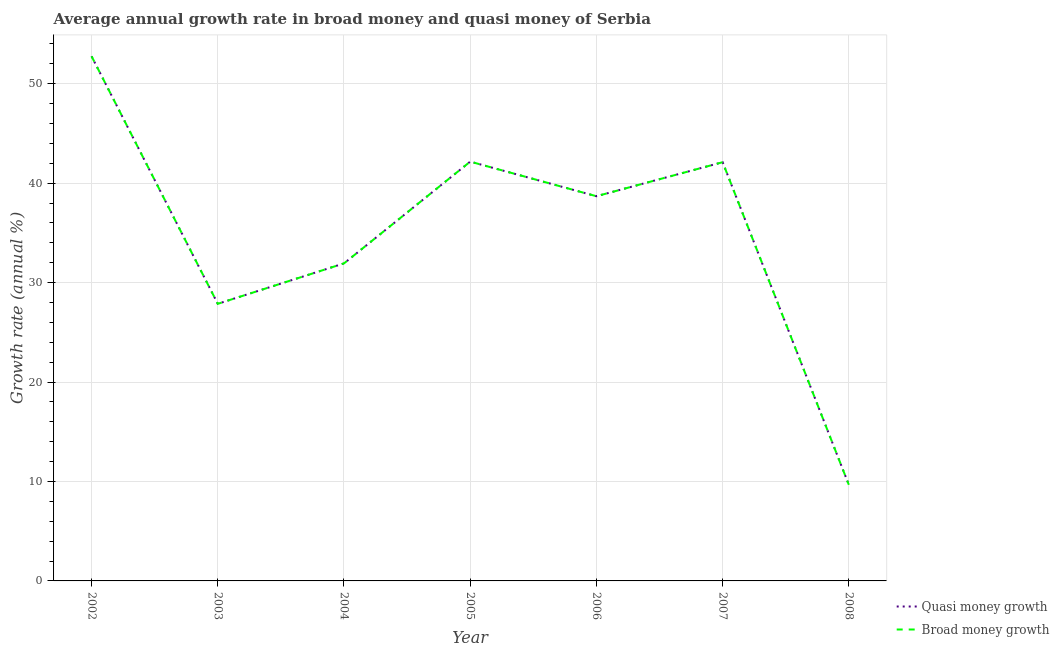How many different coloured lines are there?
Offer a terse response. 2. What is the annual growth rate in broad money in 2002?
Your response must be concise. 52.76. Across all years, what is the maximum annual growth rate in quasi money?
Offer a terse response. 52.76. Across all years, what is the minimum annual growth rate in broad money?
Your answer should be compact. 9.67. In which year was the annual growth rate in broad money maximum?
Offer a very short reply. 2002. In which year was the annual growth rate in quasi money minimum?
Offer a very short reply. 2008. What is the total annual growth rate in quasi money in the graph?
Provide a short and direct response. 245.19. What is the difference between the annual growth rate in quasi money in 2002 and that in 2006?
Provide a short and direct response. 14.07. What is the difference between the annual growth rate in quasi money in 2007 and the annual growth rate in broad money in 2005?
Your answer should be compact. -0.06. What is the average annual growth rate in broad money per year?
Provide a short and direct response. 35.03. What is the ratio of the annual growth rate in broad money in 2006 to that in 2007?
Make the answer very short. 0.92. What is the difference between the highest and the second highest annual growth rate in quasi money?
Give a very brief answer. 10.59. What is the difference between the highest and the lowest annual growth rate in quasi money?
Your response must be concise. 43.09. In how many years, is the annual growth rate in quasi money greater than the average annual growth rate in quasi money taken over all years?
Provide a succinct answer. 4. What is the difference between two consecutive major ticks on the Y-axis?
Offer a very short reply. 10. Are the values on the major ticks of Y-axis written in scientific E-notation?
Keep it short and to the point. No. Does the graph contain any zero values?
Offer a terse response. No. Does the graph contain grids?
Make the answer very short. Yes. Where does the legend appear in the graph?
Offer a very short reply. Bottom right. How many legend labels are there?
Make the answer very short. 2. How are the legend labels stacked?
Make the answer very short. Vertical. What is the title of the graph?
Offer a very short reply. Average annual growth rate in broad money and quasi money of Serbia. What is the label or title of the Y-axis?
Provide a succinct answer. Growth rate (annual %). What is the Growth rate (annual %) of Quasi money growth in 2002?
Ensure brevity in your answer.  52.76. What is the Growth rate (annual %) in Broad money growth in 2002?
Provide a succinct answer. 52.76. What is the Growth rate (annual %) in Quasi money growth in 2003?
Provide a short and direct response. 27.87. What is the Growth rate (annual %) in Broad money growth in 2003?
Offer a very short reply. 27.87. What is the Growth rate (annual %) of Quasi money growth in 2004?
Your response must be concise. 31.93. What is the Growth rate (annual %) of Broad money growth in 2004?
Offer a very short reply. 31.93. What is the Growth rate (annual %) in Quasi money growth in 2005?
Your answer should be very brief. 42.17. What is the Growth rate (annual %) of Broad money growth in 2005?
Make the answer very short. 42.17. What is the Growth rate (annual %) of Quasi money growth in 2006?
Make the answer very short. 38.69. What is the Growth rate (annual %) in Broad money growth in 2006?
Your answer should be very brief. 38.69. What is the Growth rate (annual %) of Quasi money growth in 2007?
Your response must be concise. 42.11. What is the Growth rate (annual %) in Broad money growth in 2007?
Offer a terse response. 42.11. What is the Growth rate (annual %) of Quasi money growth in 2008?
Keep it short and to the point. 9.67. What is the Growth rate (annual %) in Broad money growth in 2008?
Offer a terse response. 9.67. Across all years, what is the maximum Growth rate (annual %) of Quasi money growth?
Provide a succinct answer. 52.76. Across all years, what is the maximum Growth rate (annual %) in Broad money growth?
Provide a succinct answer. 52.76. Across all years, what is the minimum Growth rate (annual %) of Quasi money growth?
Ensure brevity in your answer.  9.67. Across all years, what is the minimum Growth rate (annual %) of Broad money growth?
Your response must be concise. 9.67. What is the total Growth rate (annual %) of Quasi money growth in the graph?
Your answer should be very brief. 245.19. What is the total Growth rate (annual %) of Broad money growth in the graph?
Offer a very short reply. 245.19. What is the difference between the Growth rate (annual %) in Quasi money growth in 2002 and that in 2003?
Provide a short and direct response. 24.89. What is the difference between the Growth rate (annual %) of Broad money growth in 2002 and that in 2003?
Give a very brief answer. 24.89. What is the difference between the Growth rate (annual %) of Quasi money growth in 2002 and that in 2004?
Your answer should be compact. 20.83. What is the difference between the Growth rate (annual %) of Broad money growth in 2002 and that in 2004?
Give a very brief answer. 20.83. What is the difference between the Growth rate (annual %) in Quasi money growth in 2002 and that in 2005?
Ensure brevity in your answer.  10.59. What is the difference between the Growth rate (annual %) of Broad money growth in 2002 and that in 2005?
Your response must be concise. 10.59. What is the difference between the Growth rate (annual %) of Quasi money growth in 2002 and that in 2006?
Offer a very short reply. 14.07. What is the difference between the Growth rate (annual %) of Broad money growth in 2002 and that in 2006?
Offer a terse response. 14.07. What is the difference between the Growth rate (annual %) in Quasi money growth in 2002 and that in 2007?
Provide a succinct answer. 10.65. What is the difference between the Growth rate (annual %) of Broad money growth in 2002 and that in 2007?
Provide a short and direct response. 10.65. What is the difference between the Growth rate (annual %) of Quasi money growth in 2002 and that in 2008?
Give a very brief answer. 43.09. What is the difference between the Growth rate (annual %) of Broad money growth in 2002 and that in 2008?
Offer a very short reply. 43.09. What is the difference between the Growth rate (annual %) of Quasi money growth in 2003 and that in 2004?
Your response must be concise. -4.06. What is the difference between the Growth rate (annual %) in Broad money growth in 2003 and that in 2004?
Your answer should be compact. -4.06. What is the difference between the Growth rate (annual %) of Quasi money growth in 2003 and that in 2005?
Your response must be concise. -14.3. What is the difference between the Growth rate (annual %) in Broad money growth in 2003 and that in 2005?
Provide a short and direct response. -14.3. What is the difference between the Growth rate (annual %) of Quasi money growth in 2003 and that in 2006?
Your answer should be compact. -10.82. What is the difference between the Growth rate (annual %) of Broad money growth in 2003 and that in 2006?
Keep it short and to the point. -10.82. What is the difference between the Growth rate (annual %) in Quasi money growth in 2003 and that in 2007?
Provide a succinct answer. -14.24. What is the difference between the Growth rate (annual %) of Broad money growth in 2003 and that in 2007?
Provide a short and direct response. -14.24. What is the difference between the Growth rate (annual %) of Quasi money growth in 2003 and that in 2008?
Make the answer very short. 18.2. What is the difference between the Growth rate (annual %) of Broad money growth in 2003 and that in 2008?
Your answer should be compact. 18.2. What is the difference between the Growth rate (annual %) in Quasi money growth in 2004 and that in 2005?
Ensure brevity in your answer.  -10.23. What is the difference between the Growth rate (annual %) in Broad money growth in 2004 and that in 2005?
Your answer should be very brief. -10.23. What is the difference between the Growth rate (annual %) of Quasi money growth in 2004 and that in 2006?
Your response must be concise. -6.76. What is the difference between the Growth rate (annual %) of Broad money growth in 2004 and that in 2006?
Ensure brevity in your answer.  -6.76. What is the difference between the Growth rate (annual %) of Quasi money growth in 2004 and that in 2007?
Offer a very short reply. -10.18. What is the difference between the Growth rate (annual %) of Broad money growth in 2004 and that in 2007?
Ensure brevity in your answer.  -10.18. What is the difference between the Growth rate (annual %) of Quasi money growth in 2004 and that in 2008?
Offer a very short reply. 22.27. What is the difference between the Growth rate (annual %) of Broad money growth in 2004 and that in 2008?
Keep it short and to the point. 22.27. What is the difference between the Growth rate (annual %) of Quasi money growth in 2005 and that in 2006?
Your answer should be very brief. 3.48. What is the difference between the Growth rate (annual %) in Broad money growth in 2005 and that in 2006?
Keep it short and to the point. 3.48. What is the difference between the Growth rate (annual %) in Quasi money growth in 2005 and that in 2007?
Your answer should be very brief. 0.06. What is the difference between the Growth rate (annual %) in Broad money growth in 2005 and that in 2007?
Make the answer very short. 0.06. What is the difference between the Growth rate (annual %) in Quasi money growth in 2005 and that in 2008?
Make the answer very short. 32.5. What is the difference between the Growth rate (annual %) of Broad money growth in 2005 and that in 2008?
Offer a very short reply. 32.5. What is the difference between the Growth rate (annual %) of Quasi money growth in 2006 and that in 2007?
Offer a very short reply. -3.42. What is the difference between the Growth rate (annual %) in Broad money growth in 2006 and that in 2007?
Your answer should be compact. -3.42. What is the difference between the Growth rate (annual %) of Quasi money growth in 2006 and that in 2008?
Keep it short and to the point. 29.02. What is the difference between the Growth rate (annual %) of Broad money growth in 2006 and that in 2008?
Offer a very short reply. 29.02. What is the difference between the Growth rate (annual %) in Quasi money growth in 2007 and that in 2008?
Provide a short and direct response. 32.44. What is the difference between the Growth rate (annual %) of Broad money growth in 2007 and that in 2008?
Keep it short and to the point. 32.44. What is the difference between the Growth rate (annual %) in Quasi money growth in 2002 and the Growth rate (annual %) in Broad money growth in 2003?
Your response must be concise. 24.89. What is the difference between the Growth rate (annual %) in Quasi money growth in 2002 and the Growth rate (annual %) in Broad money growth in 2004?
Offer a very short reply. 20.83. What is the difference between the Growth rate (annual %) of Quasi money growth in 2002 and the Growth rate (annual %) of Broad money growth in 2005?
Ensure brevity in your answer.  10.59. What is the difference between the Growth rate (annual %) of Quasi money growth in 2002 and the Growth rate (annual %) of Broad money growth in 2006?
Provide a succinct answer. 14.07. What is the difference between the Growth rate (annual %) of Quasi money growth in 2002 and the Growth rate (annual %) of Broad money growth in 2007?
Provide a succinct answer. 10.65. What is the difference between the Growth rate (annual %) of Quasi money growth in 2002 and the Growth rate (annual %) of Broad money growth in 2008?
Give a very brief answer. 43.09. What is the difference between the Growth rate (annual %) in Quasi money growth in 2003 and the Growth rate (annual %) in Broad money growth in 2004?
Give a very brief answer. -4.06. What is the difference between the Growth rate (annual %) of Quasi money growth in 2003 and the Growth rate (annual %) of Broad money growth in 2005?
Make the answer very short. -14.3. What is the difference between the Growth rate (annual %) in Quasi money growth in 2003 and the Growth rate (annual %) in Broad money growth in 2006?
Your answer should be compact. -10.82. What is the difference between the Growth rate (annual %) in Quasi money growth in 2003 and the Growth rate (annual %) in Broad money growth in 2007?
Keep it short and to the point. -14.24. What is the difference between the Growth rate (annual %) in Quasi money growth in 2003 and the Growth rate (annual %) in Broad money growth in 2008?
Offer a very short reply. 18.2. What is the difference between the Growth rate (annual %) in Quasi money growth in 2004 and the Growth rate (annual %) in Broad money growth in 2005?
Offer a terse response. -10.23. What is the difference between the Growth rate (annual %) of Quasi money growth in 2004 and the Growth rate (annual %) of Broad money growth in 2006?
Ensure brevity in your answer.  -6.76. What is the difference between the Growth rate (annual %) in Quasi money growth in 2004 and the Growth rate (annual %) in Broad money growth in 2007?
Offer a terse response. -10.18. What is the difference between the Growth rate (annual %) in Quasi money growth in 2004 and the Growth rate (annual %) in Broad money growth in 2008?
Offer a terse response. 22.27. What is the difference between the Growth rate (annual %) of Quasi money growth in 2005 and the Growth rate (annual %) of Broad money growth in 2006?
Your answer should be very brief. 3.48. What is the difference between the Growth rate (annual %) of Quasi money growth in 2005 and the Growth rate (annual %) of Broad money growth in 2007?
Provide a succinct answer. 0.06. What is the difference between the Growth rate (annual %) in Quasi money growth in 2005 and the Growth rate (annual %) in Broad money growth in 2008?
Your answer should be very brief. 32.5. What is the difference between the Growth rate (annual %) in Quasi money growth in 2006 and the Growth rate (annual %) in Broad money growth in 2007?
Your response must be concise. -3.42. What is the difference between the Growth rate (annual %) in Quasi money growth in 2006 and the Growth rate (annual %) in Broad money growth in 2008?
Keep it short and to the point. 29.02. What is the difference between the Growth rate (annual %) in Quasi money growth in 2007 and the Growth rate (annual %) in Broad money growth in 2008?
Make the answer very short. 32.44. What is the average Growth rate (annual %) in Quasi money growth per year?
Give a very brief answer. 35.03. What is the average Growth rate (annual %) in Broad money growth per year?
Your response must be concise. 35.03. In the year 2003, what is the difference between the Growth rate (annual %) of Quasi money growth and Growth rate (annual %) of Broad money growth?
Your answer should be compact. 0. In the year 2007, what is the difference between the Growth rate (annual %) in Quasi money growth and Growth rate (annual %) in Broad money growth?
Your answer should be very brief. 0. In the year 2008, what is the difference between the Growth rate (annual %) in Quasi money growth and Growth rate (annual %) in Broad money growth?
Keep it short and to the point. 0. What is the ratio of the Growth rate (annual %) in Quasi money growth in 2002 to that in 2003?
Ensure brevity in your answer.  1.89. What is the ratio of the Growth rate (annual %) in Broad money growth in 2002 to that in 2003?
Provide a succinct answer. 1.89. What is the ratio of the Growth rate (annual %) of Quasi money growth in 2002 to that in 2004?
Offer a terse response. 1.65. What is the ratio of the Growth rate (annual %) in Broad money growth in 2002 to that in 2004?
Keep it short and to the point. 1.65. What is the ratio of the Growth rate (annual %) in Quasi money growth in 2002 to that in 2005?
Ensure brevity in your answer.  1.25. What is the ratio of the Growth rate (annual %) of Broad money growth in 2002 to that in 2005?
Offer a very short reply. 1.25. What is the ratio of the Growth rate (annual %) of Quasi money growth in 2002 to that in 2006?
Your response must be concise. 1.36. What is the ratio of the Growth rate (annual %) in Broad money growth in 2002 to that in 2006?
Your response must be concise. 1.36. What is the ratio of the Growth rate (annual %) in Quasi money growth in 2002 to that in 2007?
Offer a very short reply. 1.25. What is the ratio of the Growth rate (annual %) of Broad money growth in 2002 to that in 2007?
Provide a succinct answer. 1.25. What is the ratio of the Growth rate (annual %) of Quasi money growth in 2002 to that in 2008?
Provide a short and direct response. 5.46. What is the ratio of the Growth rate (annual %) of Broad money growth in 2002 to that in 2008?
Make the answer very short. 5.46. What is the ratio of the Growth rate (annual %) of Quasi money growth in 2003 to that in 2004?
Offer a very short reply. 0.87. What is the ratio of the Growth rate (annual %) of Broad money growth in 2003 to that in 2004?
Keep it short and to the point. 0.87. What is the ratio of the Growth rate (annual %) of Quasi money growth in 2003 to that in 2005?
Ensure brevity in your answer.  0.66. What is the ratio of the Growth rate (annual %) of Broad money growth in 2003 to that in 2005?
Offer a very short reply. 0.66. What is the ratio of the Growth rate (annual %) in Quasi money growth in 2003 to that in 2006?
Your answer should be very brief. 0.72. What is the ratio of the Growth rate (annual %) of Broad money growth in 2003 to that in 2006?
Keep it short and to the point. 0.72. What is the ratio of the Growth rate (annual %) of Quasi money growth in 2003 to that in 2007?
Offer a very short reply. 0.66. What is the ratio of the Growth rate (annual %) of Broad money growth in 2003 to that in 2007?
Provide a succinct answer. 0.66. What is the ratio of the Growth rate (annual %) of Quasi money growth in 2003 to that in 2008?
Give a very brief answer. 2.88. What is the ratio of the Growth rate (annual %) in Broad money growth in 2003 to that in 2008?
Provide a succinct answer. 2.88. What is the ratio of the Growth rate (annual %) of Quasi money growth in 2004 to that in 2005?
Your answer should be compact. 0.76. What is the ratio of the Growth rate (annual %) in Broad money growth in 2004 to that in 2005?
Offer a terse response. 0.76. What is the ratio of the Growth rate (annual %) of Quasi money growth in 2004 to that in 2006?
Offer a very short reply. 0.83. What is the ratio of the Growth rate (annual %) in Broad money growth in 2004 to that in 2006?
Provide a short and direct response. 0.83. What is the ratio of the Growth rate (annual %) of Quasi money growth in 2004 to that in 2007?
Ensure brevity in your answer.  0.76. What is the ratio of the Growth rate (annual %) in Broad money growth in 2004 to that in 2007?
Provide a short and direct response. 0.76. What is the ratio of the Growth rate (annual %) of Quasi money growth in 2004 to that in 2008?
Make the answer very short. 3.3. What is the ratio of the Growth rate (annual %) in Broad money growth in 2004 to that in 2008?
Provide a short and direct response. 3.3. What is the ratio of the Growth rate (annual %) in Quasi money growth in 2005 to that in 2006?
Your response must be concise. 1.09. What is the ratio of the Growth rate (annual %) in Broad money growth in 2005 to that in 2006?
Provide a succinct answer. 1.09. What is the ratio of the Growth rate (annual %) in Broad money growth in 2005 to that in 2007?
Offer a very short reply. 1. What is the ratio of the Growth rate (annual %) of Quasi money growth in 2005 to that in 2008?
Offer a very short reply. 4.36. What is the ratio of the Growth rate (annual %) in Broad money growth in 2005 to that in 2008?
Offer a terse response. 4.36. What is the ratio of the Growth rate (annual %) of Quasi money growth in 2006 to that in 2007?
Give a very brief answer. 0.92. What is the ratio of the Growth rate (annual %) of Broad money growth in 2006 to that in 2007?
Make the answer very short. 0.92. What is the ratio of the Growth rate (annual %) in Quasi money growth in 2006 to that in 2008?
Ensure brevity in your answer.  4. What is the ratio of the Growth rate (annual %) in Broad money growth in 2006 to that in 2008?
Your answer should be compact. 4. What is the ratio of the Growth rate (annual %) of Quasi money growth in 2007 to that in 2008?
Your answer should be compact. 4.36. What is the ratio of the Growth rate (annual %) in Broad money growth in 2007 to that in 2008?
Give a very brief answer. 4.36. What is the difference between the highest and the second highest Growth rate (annual %) in Quasi money growth?
Your answer should be compact. 10.59. What is the difference between the highest and the second highest Growth rate (annual %) in Broad money growth?
Offer a terse response. 10.59. What is the difference between the highest and the lowest Growth rate (annual %) in Quasi money growth?
Offer a very short reply. 43.09. What is the difference between the highest and the lowest Growth rate (annual %) of Broad money growth?
Keep it short and to the point. 43.09. 